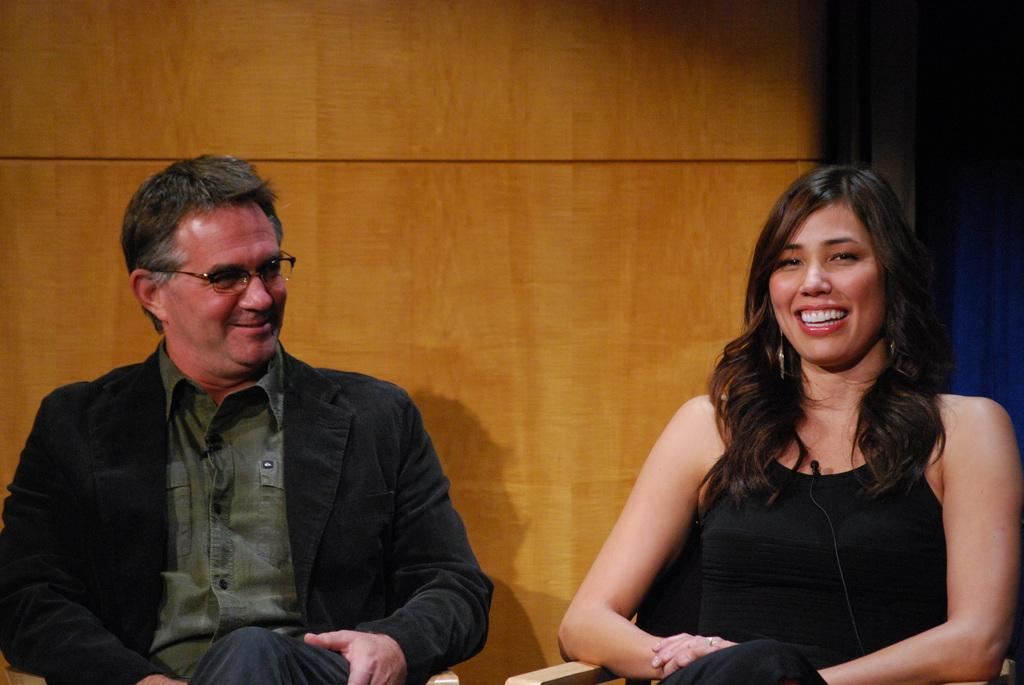How many people are sitting in the image? There are two people sitting in the image. What colors are the people wearing? Both people are wearing black and green colors. Can you describe any accessories worn by the people? One person is wearing specs. What can be seen in the background of the image? There is a brown color wall in the background. What type of volleyball game is being played in the image? There is no volleyball game present in the image. How many pigs are visible in the image? There are no pigs visible in the image. 